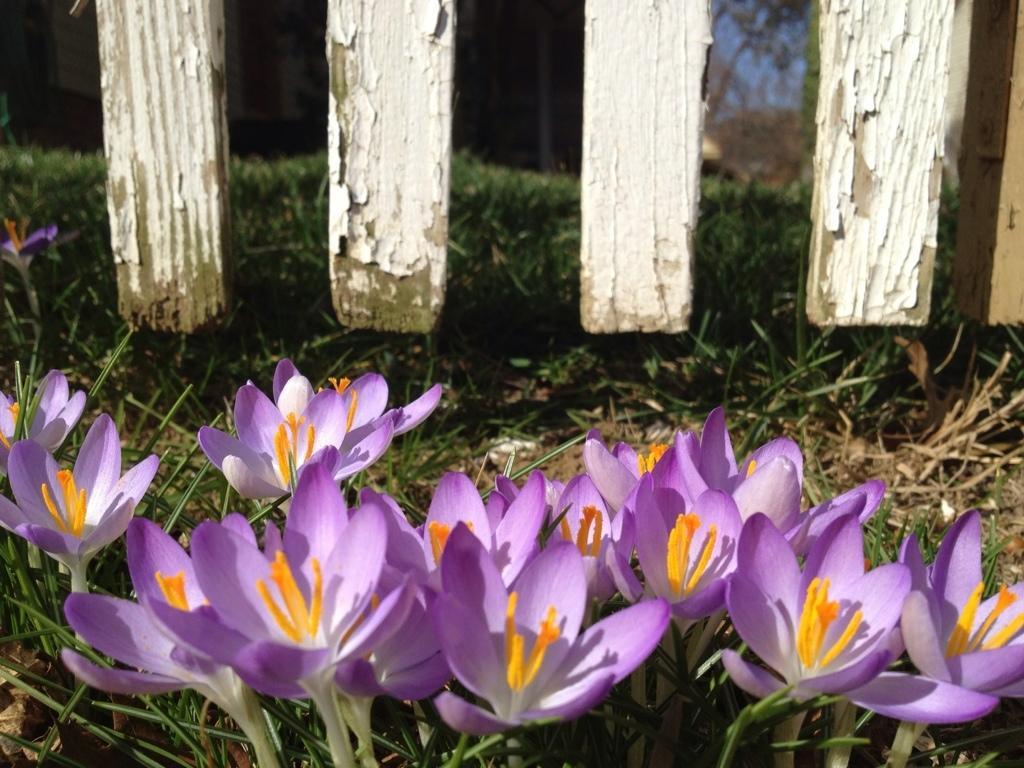Could you give a brief overview of what you see in this image? At the bottom of the image we can see flowers and grass. 